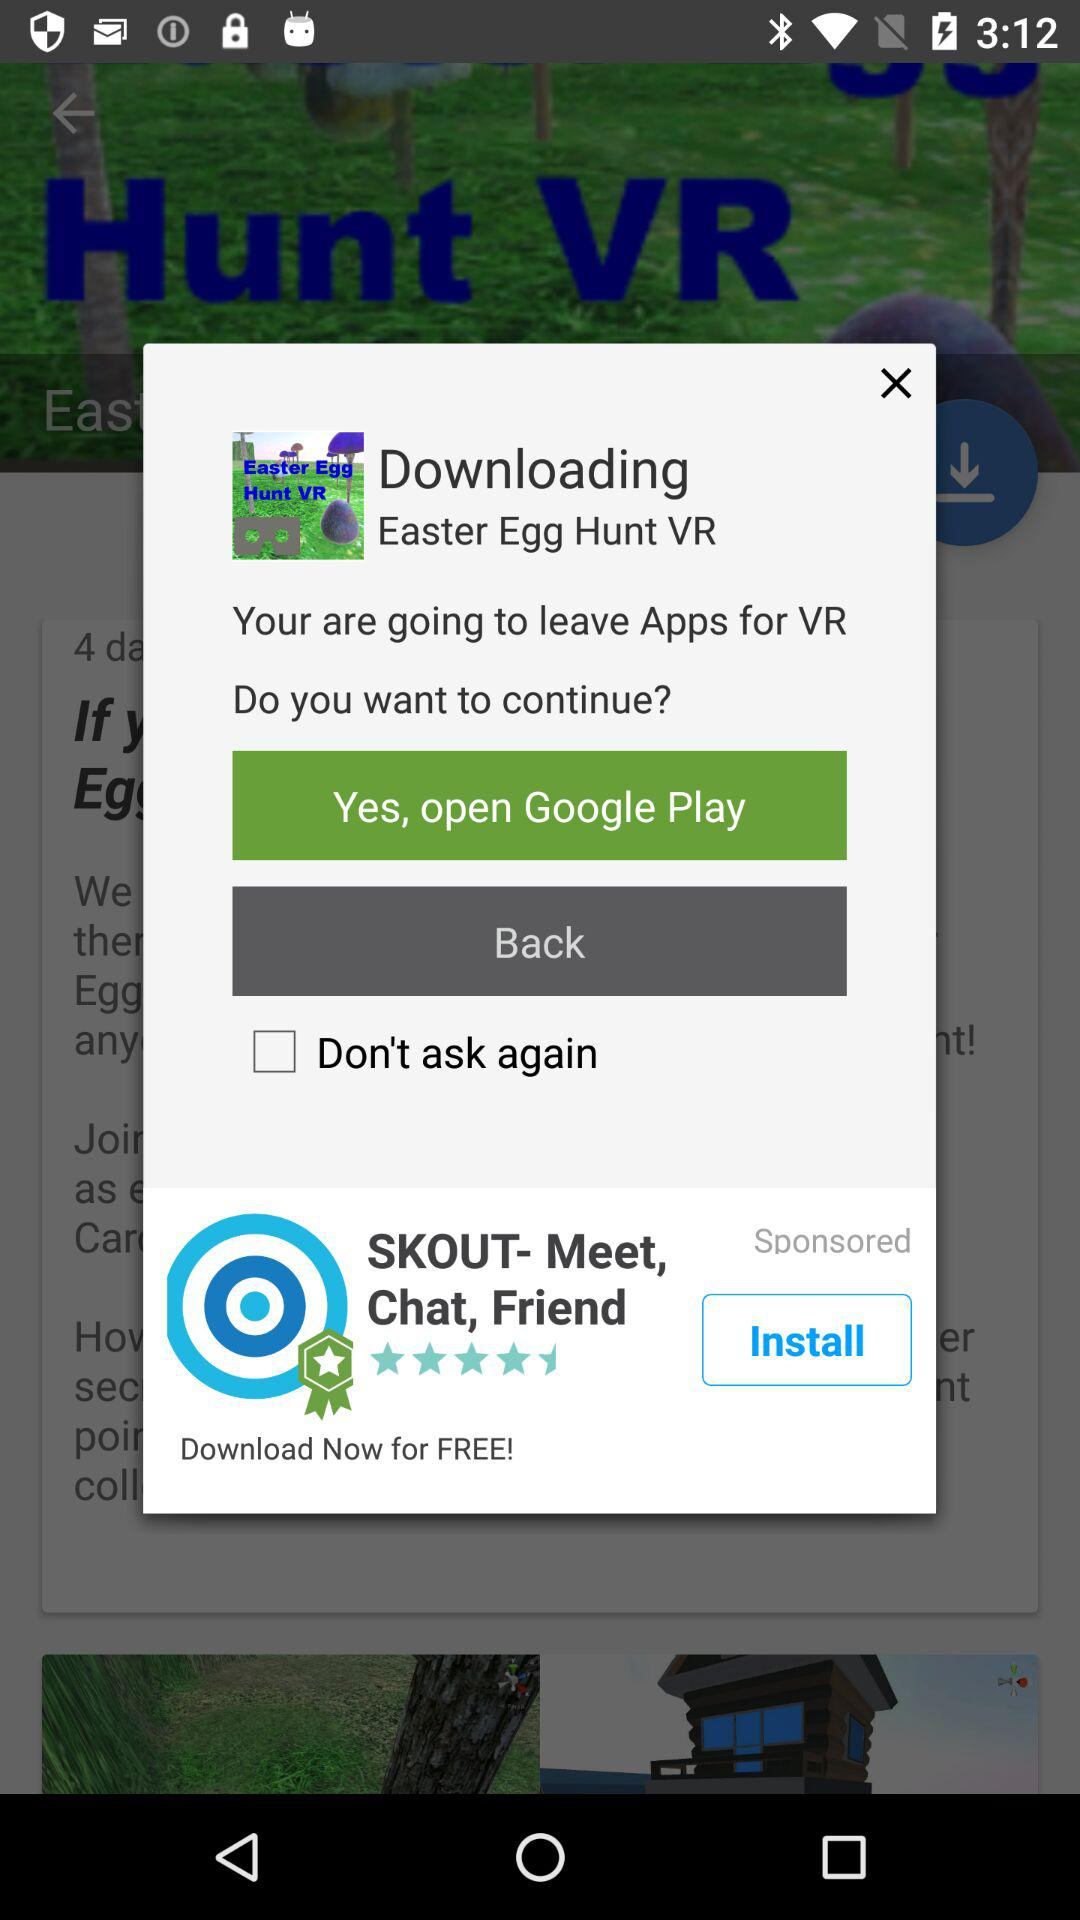What is the status of "Don't ask again"? The status is off. 